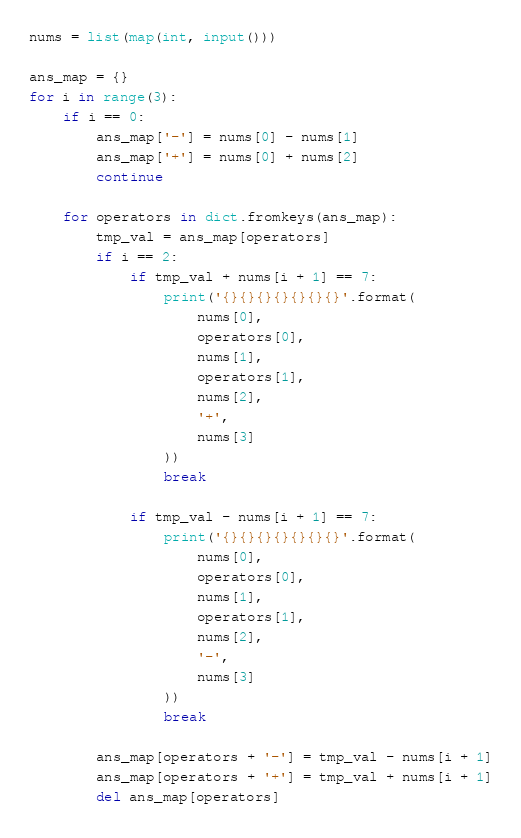<code> <loc_0><loc_0><loc_500><loc_500><_Python_>nums = list(map(int, input()))

ans_map = {}
for i in range(3):
    if i == 0:
        ans_map['-'] = nums[0] - nums[1]
        ans_map['+'] = nums[0] + nums[2]
        continue

    for operators in dict.fromkeys(ans_map):
        tmp_val = ans_map[operators]
        if i == 2:
            if tmp_val + nums[i + 1] == 7:
                print('{}{}{}{}{}{}{}'.format(
                    nums[0],
                    operators[0],
                    nums[1],
                    operators[1],
                    nums[2],
                    '+',
                    nums[3]
                ))
                break

            if tmp_val - nums[i + 1] == 7:
                print('{}{}{}{}{}{}{}'.format(
                    nums[0],
                    operators[0],
                    nums[1],
                    operators[1],
                    nums[2],
                    '-',
                    nums[3]
                ))
                break

        ans_map[operators + '-'] = tmp_val - nums[i + 1]
        ans_map[operators + '+'] = tmp_val + nums[i + 1]
        del ans_map[operators]</code> 